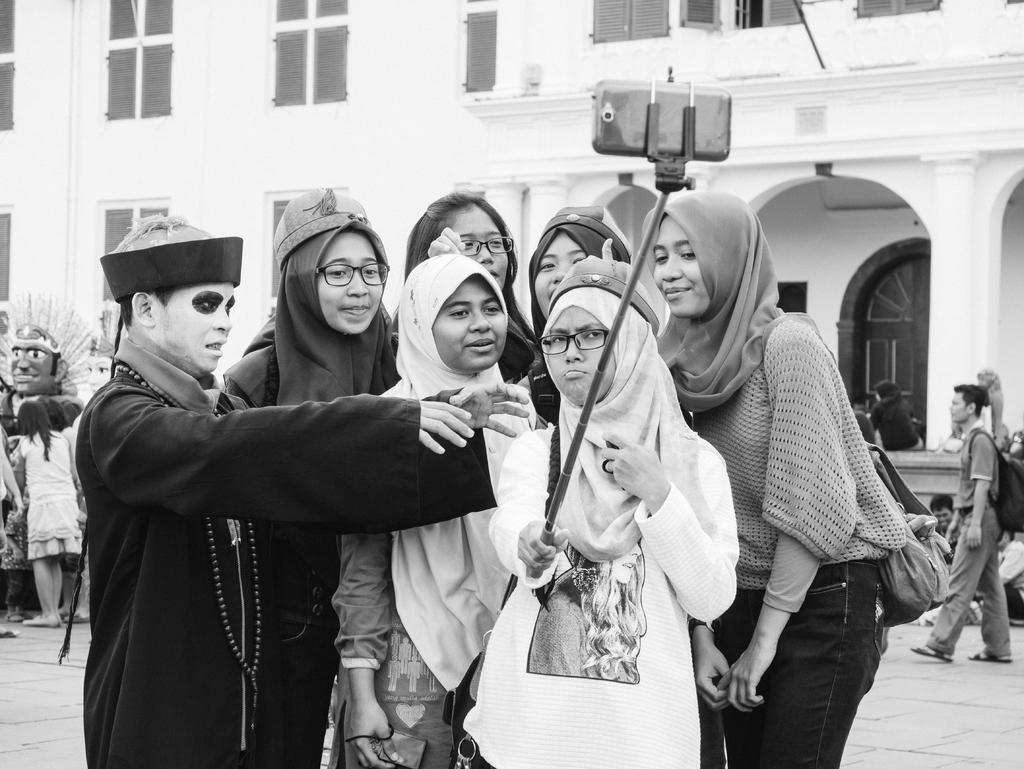How would you summarize this image in a sentence or two? In this picture we can see some people standing here, a woman in the front is holding a selfie stick, in the background there is a building, we can see a person walking on the right side, there are some windows of the building here. 